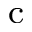Convert formula to latex. <formula><loc_0><loc_0><loc_500><loc_500>_ { c }</formula> 